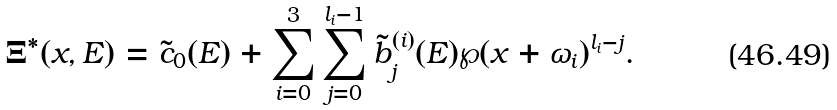<formula> <loc_0><loc_0><loc_500><loc_500>\Xi ^ { * } ( x , E ) = \tilde { c } _ { 0 } ( E ) + \sum _ { i = 0 } ^ { 3 } \sum _ { j = 0 } ^ { l _ { i } - 1 } \tilde { b } ^ { ( i ) } _ { j } ( E ) \wp ( x + \omega _ { i } ) ^ { l _ { i } - j } .</formula> 